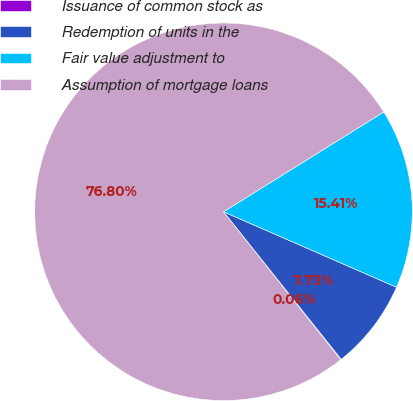Convert chart. <chart><loc_0><loc_0><loc_500><loc_500><pie_chart><fcel>Issuance of common stock as<fcel>Redemption of units in the<fcel>Fair value adjustment to<fcel>Assumption of mortgage loans<nl><fcel>0.06%<fcel>7.73%<fcel>15.41%<fcel>76.8%<nl></chart> 